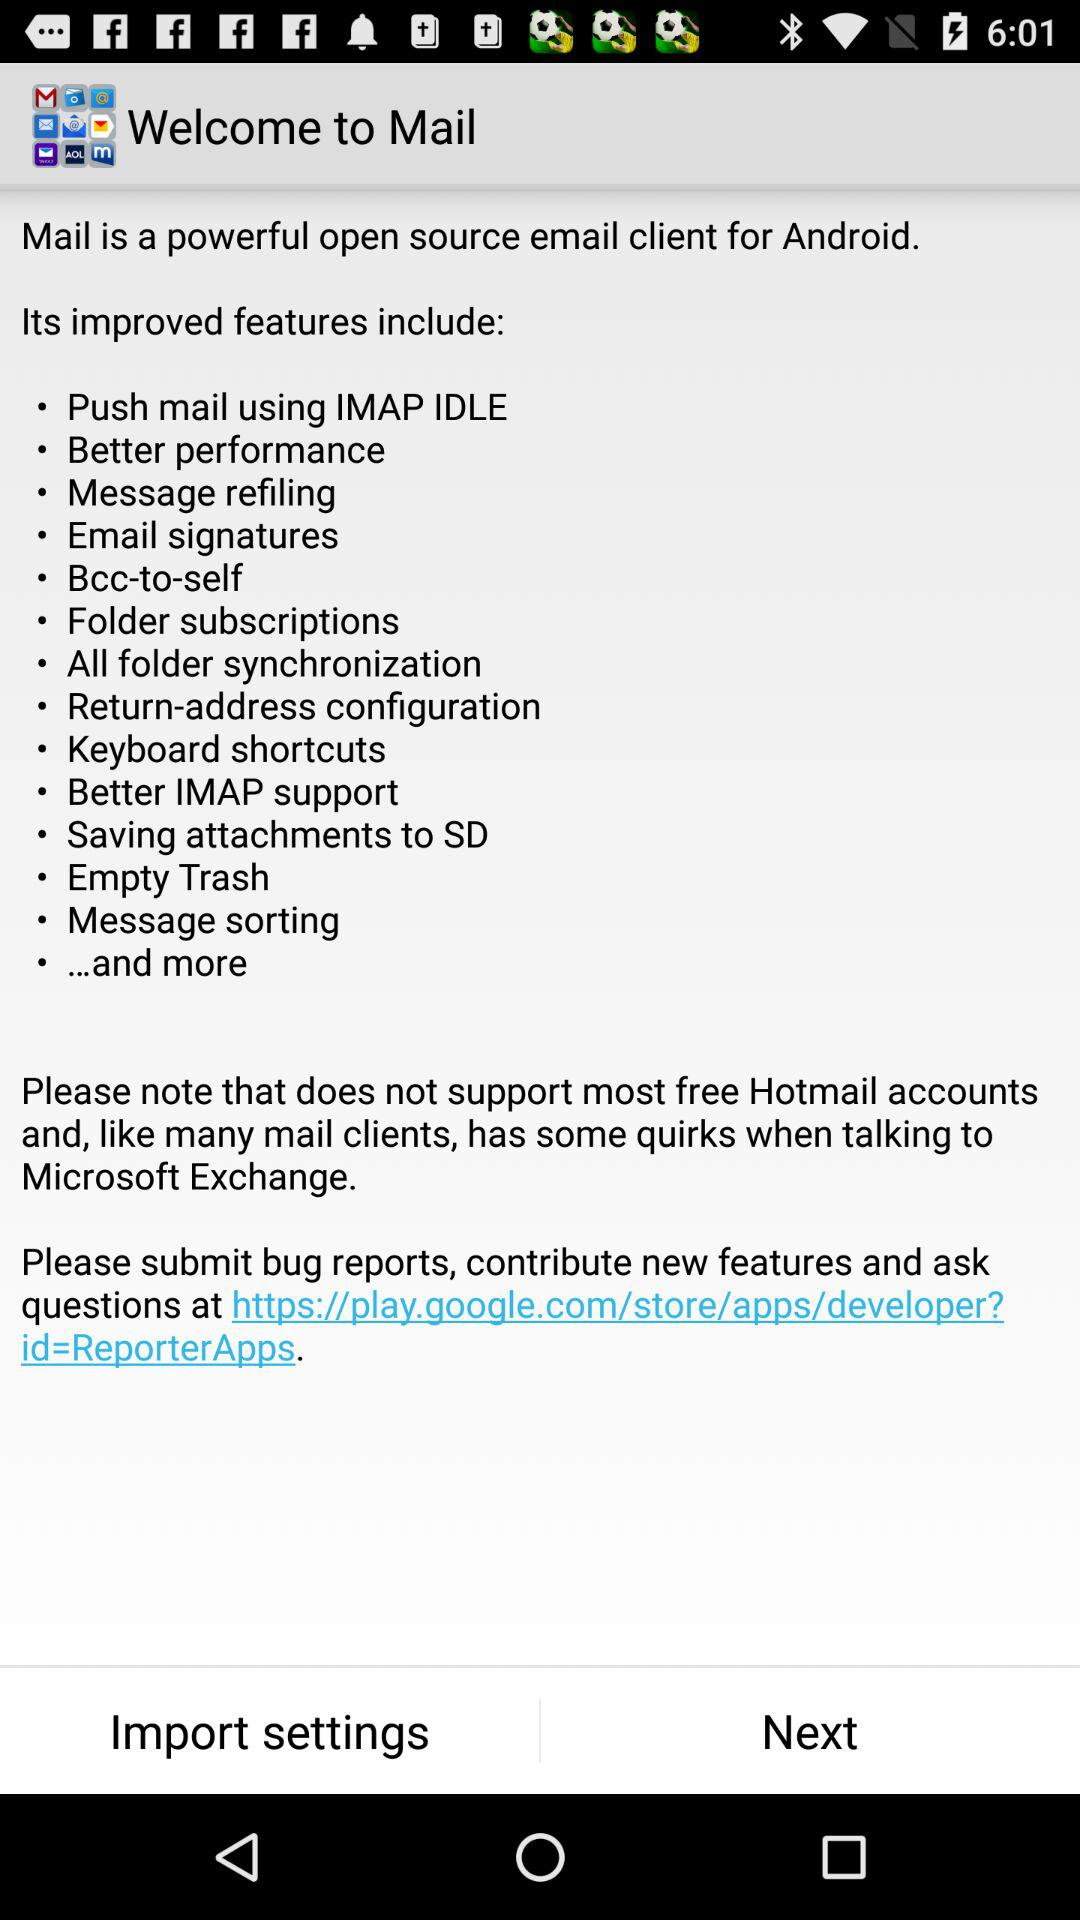What is the app name? The app name is "Mail". 